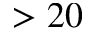Convert formula to latex. <formula><loc_0><loc_0><loc_500><loc_500>> 2 0</formula> 